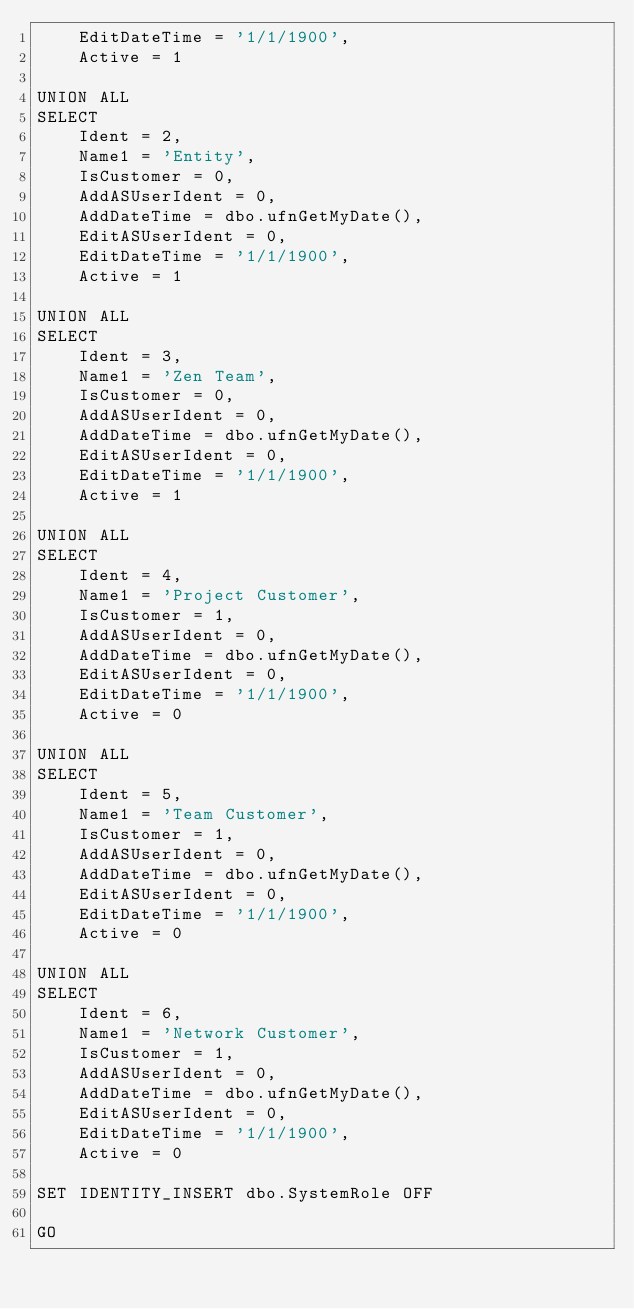Convert code to text. <code><loc_0><loc_0><loc_500><loc_500><_SQL_>	EditDateTime = '1/1/1900',
	Active = 1

UNION ALL
SELECT
	Ident = 2,
	Name1 = 'Entity',
	IsCustomer = 0,
	AddASUserIdent = 0,
	AddDateTime = dbo.ufnGetMyDate(),
	EditASUserIdent = 0,
	EditDateTime = '1/1/1900',
	Active = 1

UNION ALL
SELECT
	Ident = 3,
	Name1 = 'Zen Team',
	IsCustomer = 0,
	AddASUserIdent = 0,
	AddDateTime = dbo.ufnGetMyDate(),
	EditASUserIdent = 0,
	EditDateTime = '1/1/1900',
	Active = 1

UNION ALL
SELECT
	Ident = 4,
	Name1 = 'Project Customer',
	IsCustomer = 1,
	AddASUserIdent = 0,
	AddDateTime = dbo.ufnGetMyDate(),
	EditASUserIdent = 0,
	EditDateTime = '1/1/1900',
	Active = 0

UNION ALL
SELECT
	Ident = 5,
	Name1 = 'Team Customer',
	IsCustomer = 1,
	AddASUserIdent = 0,
	AddDateTime = dbo.ufnGetMyDate(),
	EditASUserIdent = 0,
	EditDateTime = '1/1/1900',
	Active = 0

UNION ALL
SELECT
	Ident = 6,
	Name1 = 'Network Customer',
	IsCustomer = 1,
	AddASUserIdent = 0,
	AddDateTime = dbo.ufnGetMyDate(),
	EditASUserIdent = 0,
	EditDateTime = '1/1/1900',
	Active = 0

SET IDENTITY_INSERT dbo.SystemRole OFF

GO</code> 